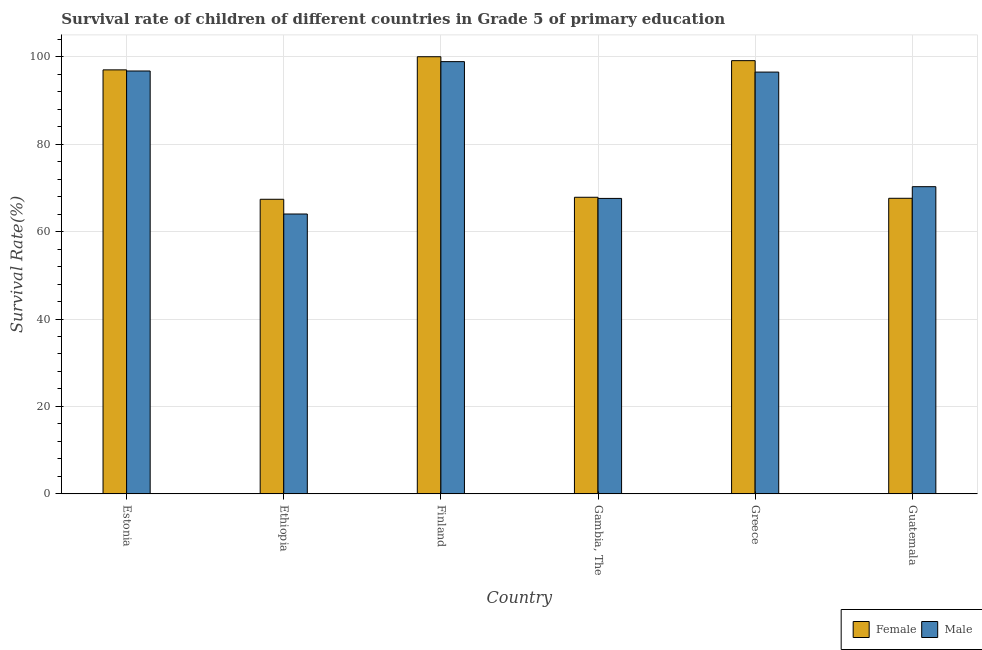How many different coloured bars are there?
Your answer should be compact. 2. Are the number of bars per tick equal to the number of legend labels?
Give a very brief answer. Yes. Are the number of bars on each tick of the X-axis equal?
Give a very brief answer. Yes. How many bars are there on the 2nd tick from the left?
Provide a succinct answer. 2. How many bars are there on the 2nd tick from the right?
Your response must be concise. 2. What is the label of the 1st group of bars from the left?
Ensure brevity in your answer.  Estonia. In how many cases, is the number of bars for a given country not equal to the number of legend labels?
Offer a very short reply. 0. What is the survival rate of female students in primary education in Guatemala?
Provide a succinct answer. 67.62. Across all countries, what is the maximum survival rate of male students in primary education?
Give a very brief answer. 98.88. Across all countries, what is the minimum survival rate of female students in primary education?
Keep it short and to the point. 67.39. In which country was the survival rate of female students in primary education maximum?
Keep it short and to the point. Finland. In which country was the survival rate of female students in primary education minimum?
Keep it short and to the point. Ethiopia. What is the total survival rate of male students in primary education in the graph?
Make the answer very short. 493.99. What is the difference between the survival rate of male students in primary education in Ethiopia and that in Greece?
Your answer should be compact. -32.47. What is the difference between the survival rate of female students in primary education in Ethiopia and the survival rate of male students in primary education in Greece?
Offer a terse response. -29.1. What is the average survival rate of female students in primary education per country?
Offer a terse response. 83.16. What is the difference between the survival rate of male students in primary education and survival rate of female students in primary education in Gambia, The?
Keep it short and to the point. -0.26. In how many countries, is the survival rate of female students in primary education greater than 88 %?
Provide a succinct answer. 3. What is the ratio of the survival rate of female students in primary education in Gambia, The to that in Greece?
Your response must be concise. 0.68. Is the survival rate of male students in primary education in Ethiopia less than that in Gambia, The?
Your answer should be very brief. Yes. Is the difference between the survival rate of female students in primary education in Ethiopia and Finland greater than the difference between the survival rate of male students in primary education in Ethiopia and Finland?
Make the answer very short. Yes. What is the difference between the highest and the second highest survival rate of female students in primary education?
Offer a very short reply. 0.9. What is the difference between the highest and the lowest survival rate of male students in primary education?
Make the answer very short. 34.86. In how many countries, is the survival rate of male students in primary education greater than the average survival rate of male students in primary education taken over all countries?
Your response must be concise. 3. Is the sum of the survival rate of male students in primary education in Greece and Guatemala greater than the maximum survival rate of female students in primary education across all countries?
Make the answer very short. Yes. What does the 2nd bar from the right in Greece represents?
Your response must be concise. Female. How many bars are there?
Ensure brevity in your answer.  12. Are all the bars in the graph horizontal?
Ensure brevity in your answer.  No. What is the difference between two consecutive major ticks on the Y-axis?
Provide a succinct answer. 20. Does the graph contain any zero values?
Offer a terse response. No. Does the graph contain grids?
Your response must be concise. Yes. How many legend labels are there?
Provide a succinct answer. 2. How are the legend labels stacked?
Your response must be concise. Horizontal. What is the title of the graph?
Your answer should be very brief. Survival rate of children of different countries in Grade 5 of primary education. Does "From Government" appear as one of the legend labels in the graph?
Provide a succinct answer. No. What is the label or title of the Y-axis?
Your answer should be very brief. Survival Rate(%). What is the Survival Rate(%) of Female in Estonia?
Your answer should be compact. 96.99. What is the Survival Rate(%) of Male in Estonia?
Your answer should be very brief. 96.74. What is the Survival Rate(%) of Female in Ethiopia?
Give a very brief answer. 67.39. What is the Survival Rate(%) of Male in Ethiopia?
Offer a terse response. 64.02. What is the Survival Rate(%) in Male in Finland?
Make the answer very short. 98.88. What is the Survival Rate(%) of Female in Gambia, The?
Your response must be concise. 67.85. What is the Survival Rate(%) of Male in Gambia, The?
Give a very brief answer. 67.59. What is the Survival Rate(%) of Female in Greece?
Offer a terse response. 99.1. What is the Survival Rate(%) in Male in Greece?
Offer a terse response. 96.49. What is the Survival Rate(%) of Female in Guatemala?
Offer a very short reply. 67.62. What is the Survival Rate(%) of Male in Guatemala?
Your answer should be compact. 70.27. Across all countries, what is the maximum Survival Rate(%) of Male?
Provide a short and direct response. 98.88. Across all countries, what is the minimum Survival Rate(%) in Female?
Your answer should be very brief. 67.39. Across all countries, what is the minimum Survival Rate(%) in Male?
Keep it short and to the point. 64.02. What is the total Survival Rate(%) of Female in the graph?
Ensure brevity in your answer.  498.95. What is the total Survival Rate(%) in Male in the graph?
Your answer should be compact. 493.99. What is the difference between the Survival Rate(%) in Female in Estonia and that in Ethiopia?
Give a very brief answer. 29.6. What is the difference between the Survival Rate(%) in Male in Estonia and that in Ethiopia?
Give a very brief answer. 32.72. What is the difference between the Survival Rate(%) of Female in Estonia and that in Finland?
Provide a short and direct response. -3.01. What is the difference between the Survival Rate(%) in Male in Estonia and that in Finland?
Ensure brevity in your answer.  -2.14. What is the difference between the Survival Rate(%) in Female in Estonia and that in Gambia, The?
Provide a short and direct response. 29.15. What is the difference between the Survival Rate(%) of Male in Estonia and that in Gambia, The?
Provide a succinct answer. 29.15. What is the difference between the Survival Rate(%) in Female in Estonia and that in Greece?
Your response must be concise. -2.11. What is the difference between the Survival Rate(%) in Male in Estonia and that in Greece?
Keep it short and to the point. 0.25. What is the difference between the Survival Rate(%) of Female in Estonia and that in Guatemala?
Your response must be concise. 29.38. What is the difference between the Survival Rate(%) in Male in Estonia and that in Guatemala?
Your response must be concise. 26.47. What is the difference between the Survival Rate(%) in Female in Ethiopia and that in Finland?
Ensure brevity in your answer.  -32.61. What is the difference between the Survival Rate(%) of Male in Ethiopia and that in Finland?
Keep it short and to the point. -34.86. What is the difference between the Survival Rate(%) in Female in Ethiopia and that in Gambia, The?
Ensure brevity in your answer.  -0.46. What is the difference between the Survival Rate(%) of Male in Ethiopia and that in Gambia, The?
Provide a succinct answer. -3.57. What is the difference between the Survival Rate(%) in Female in Ethiopia and that in Greece?
Provide a short and direct response. -31.71. What is the difference between the Survival Rate(%) of Male in Ethiopia and that in Greece?
Provide a short and direct response. -32.47. What is the difference between the Survival Rate(%) of Female in Ethiopia and that in Guatemala?
Provide a short and direct response. -0.23. What is the difference between the Survival Rate(%) in Male in Ethiopia and that in Guatemala?
Make the answer very short. -6.25. What is the difference between the Survival Rate(%) of Female in Finland and that in Gambia, The?
Offer a very short reply. 32.15. What is the difference between the Survival Rate(%) of Male in Finland and that in Gambia, The?
Your answer should be very brief. 31.29. What is the difference between the Survival Rate(%) in Female in Finland and that in Greece?
Your answer should be very brief. 0.9. What is the difference between the Survival Rate(%) in Male in Finland and that in Greece?
Make the answer very short. 2.39. What is the difference between the Survival Rate(%) in Female in Finland and that in Guatemala?
Your answer should be very brief. 32.38. What is the difference between the Survival Rate(%) in Male in Finland and that in Guatemala?
Provide a short and direct response. 28.61. What is the difference between the Survival Rate(%) in Female in Gambia, The and that in Greece?
Your answer should be very brief. -31.26. What is the difference between the Survival Rate(%) of Male in Gambia, The and that in Greece?
Give a very brief answer. -28.9. What is the difference between the Survival Rate(%) in Female in Gambia, The and that in Guatemala?
Provide a short and direct response. 0.23. What is the difference between the Survival Rate(%) of Male in Gambia, The and that in Guatemala?
Keep it short and to the point. -2.68. What is the difference between the Survival Rate(%) of Female in Greece and that in Guatemala?
Your response must be concise. 31.48. What is the difference between the Survival Rate(%) of Male in Greece and that in Guatemala?
Ensure brevity in your answer.  26.21. What is the difference between the Survival Rate(%) of Female in Estonia and the Survival Rate(%) of Male in Ethiopia?
Your answer should be very brief. 32.97. What is the difference between the Survival Rate(%) in Female in Estonia and the Survival Rate(%) in Male in Finland?
Offer a very short reply. -1.89. What is the difference between the Survival Rate(%) of Female in Estonia and the Survival Rate(%) of Male in Gambia, The?
Keep it short and to the point. 29.41. What is the difference between the Survival Rate(%) in Female in Estonia and the Survival Rate(%) in Male in Greece?
Keep it short and to the point. 0.51. What is the difference between the Survival Rate(%) in Female in Estonia and the Survival Rate(%) in Male in Guatemala?
Provide a succinct answer. 26.72. What is the difference between the Survival Rate(%) of Female in Ethiopia and the Survival Rate(%) of Male in Finland?
Your answer should be compact. -31.49. What is the difference between the Survival Rate(%) of Female in Ethiopia and the Survival Rate(%) of Male in Gambia, The?
Provide a succinct answer. -0.2. What is the difference between the Survival Rate(%) in Female in Ethiopia and the Survival Rate(%) in Male in Greece?
Your answer should be compact. -29.1. What is the difference between the Survival Rate(%) of Female in Ethiopia and the Survival Rate(%) of Male in Guatemala?
Give a very brief answer. -2.88. What is the difference between the Survival Rate(%) of Female in Finland and the Survival Rate(%) of Male in Gambia, The?
Your response must be concise. 32.41. What is the difference between the Survival Rate(%) in Female in Finland and the Survival Rate(%) in Male in Greece?
Ensure brevity in your answer.  3.51. What is the difference between the Survival Rate(%) in Female in Finland and the Survival Rate(%) in Male in Guatemala?
Offer a very short reply. 29.73. What is the difference between the Survival Rate(%) of Female in Gambia, The and the Survival Rate(%) of Male in Greece?
Ensure brevity in your answer.  -28.64. What is the difference between the Survival Rate(%) in Female in Gambia, The and the Survival Rate(%) in Male in Guatemala?
Give a very brief answer. -2.42. What is the difference between the Survival Rate(%) in Female in Greece and the Survival Rate(%) in Male in Guatemala?
Keep it short and to the point. 28.83. What is the average Survival Rate(%) of Female per country?
Make the answer very short. 83.16. What is the average Survival Rate(%) in Male per country?
Give a very brief answer. 82.33. What is the difference between the Survival Rate(%) of Female and Survival Rate(%) of Male in Estonia?
Provide a short and direct response. 0.25. What is the difference between the Survival Rate(%) in Female and Survival Rate(%) in Male in Ethiopia?
Your answer should be compact. 3.37. What is the difference between the Survival Rate(%) in Female and Survival Rate(%) in Male in Finland?
Your answer should be very brief. 1.12. What is the difference between the Survival Rate(%) of Female and Survival Rate(%) of Male in Gambia, The?
Your response must be concise. 0.26. What is the difference between the Survival Rate(%) in Female and Survival Rate(%) in Male in Greece?
Your response must be concise. 2.62. What is the difference between the Survival Rate(%) of Female and Survival Rate(%) of Male in Guatemala?
Give a very brief answer. -2.65. What is the ratio of the Survival Rate(%) of Female in Estonia to that in Ethiopia?
Provide a succinct answer. 1.44. What is the ratio of the Survival Rate(%) in Male in Estonia to that in Ethiopia?
Provide a succinct answer. 1.51. What is the ratio of the Survival Rate(%) of Female in Estonia to that in Finland?
Offer a very short reply. 0.97. What is the ratio of the Survival Rate(%) of Male in Estonia to that in Finland?
Your answer should be very brief. 0.98. What is the ratio of the Survival Rate(%) in Female in Estonia to that in Gambia, The?
Provide a succinct answer. 1.43. What is the ratio of the Survival Rate(%) in Male in Estonia to that in Gambia, The?
Offer a very short reply. 1.43. What is the ratio of the Survival Rate(%) of Female in Estonia to that in Greece?
Ensure brevity in your answer.  0.98. What is the ratio of the Survival Rate(%) in Male in Estonia to that in Greece?
Offer a very short reply. 1. What is the ratio of the Survival Rate(%) of Female in Estonia to that in Guatemala?
Keep it short and to the point. 1.43. What is the ratio of the Survival Rate(%) of Male in Estonia to that in Guatemala?
Your answer should be very brief. 1.38. What is the ratio of the Survival Rate(%) of Female in Ethiopia to that in Finland?
Make the answer very short. 0.67. What is the ratio of the Survival Rate(%) in Male in Ethiopia to that in Finland?
Offer a terse response. 0.65. What is the ratio of the Survival Rate(%) in Female in Ethiopia to that in Gambia, The?
Your response must be concise. 0.99. What is the ratio of the Survival Rate(%) of Male in Ethiopia to that in Gambia, The?
Your answer should be compact. 0.95. What is the ratio of the Survival Rate(%) of Female in Ethiopia to that in Greece?
Provide a succinct answer. 0.68. What is the ratio of the Survival Rate(%) in Male in Ethiopia to that in Greece?
Keep it short and to the point. 0.66. What is the ratio of the Survival Rate(%) of Male in Ethiopia to that in Guatemala?
Offer a very short reply. 0.91. What is the ratio of the Survival Rate(%) of Female in Finland to that in Gambia, The?
Offer a terse response. 1.47. What is the ratio of the Survival Rate(%) in Male in Finland to that in Gambia, The?
Ensure brevity in your answer.  1.46. What is the ratio of the Survival Rate(%) in Female in Finland to that in Greece?
Give a very brief answer. 1.01. What is the ratio of the Survival Rate(%) of Male in Finland to that in Greece?
Offer a terse response. 1.02. What is the ratio of the Survival Rate(%) in Female in Finland to that in Guatemala?
Your answer should be very brief. 1.48. What is the ratio of the Survival Rate(%) in Male in Finland to that in Guatemala?
Offer a very short reply. 1.41. What is the ratio of the Survival Rate(%) in Female in Gambia, The to that in Greece?
Offer a terse response. 0.68. What is the ratio of the Survival Rate(%) of Male in Gambia, The to that in Greece?
Make the answer very short. 0.7. What is the ratio of the Survival Rate(%) of Female in Gambia, The to that in Guatemala?
Your answer should be very brief. 1. What is the ratio of the Survival Rate(%) of Male in Gambia, The to that in Guatemala?
Ensure brevity in your answer.  0.96. What is the ratio of the Survival Rate(%) of Female in Greece to that in Guatemala?
Your answer should be very brief. 1.47. What is the ratio of the Survival Rate(%) of Male in Greece to that in Guatemala?
Ensure brevity in your answer.  1.37. What is the difference between the highest and the second highest Survival Rate(%) of Female?
Offer a terse response. 0.9. What is the difference between the highest and the second highest Survival Rate(%) of Male?
Ensure brevity in your answer.  2.14. What is the difference between the highest and the lowest Survival Rate(%) of Female?
Keep it short and to the point. 32.61. What is the difference between the highest and the lowest Survival Rate(%) of Male?
Ensure brevity in your answer.  34.86. 